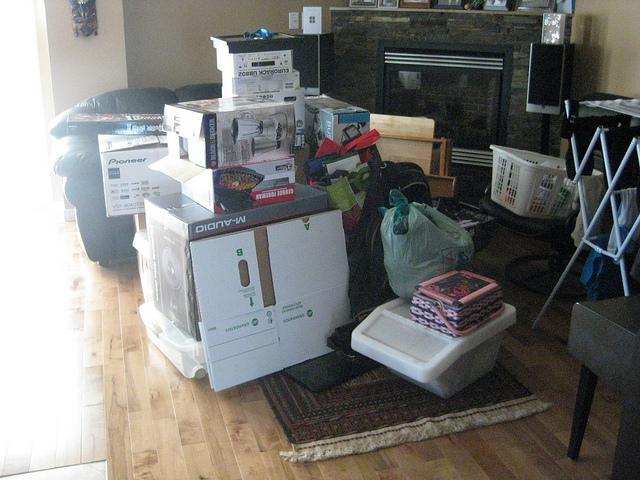Is the room organized?
Write a very short answer. No. What is the floor made out of?
Concise answer only. Wood. What type of room is this?
Answer briefly. Living room. Does it look like someone went shopping?
Concise answer only. Yes. 